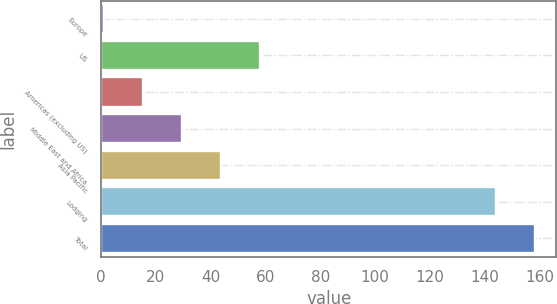Convert chart to OTSL. <chart><loc_0><loc_0><loc_500><loc_500><bar_chart><fcel>Europe<fcel>US<fcel>Americas (excluding US)<fcel>Middle East and Africa<fcel>Asia Pacific<fcel>Lodging<fcel>Total<nl><fcel>1<fcel>58.2<fcel>15.3<fcel>29.6<fcel>43.9<fcel>144<fcel>158.3<nl></chart> 